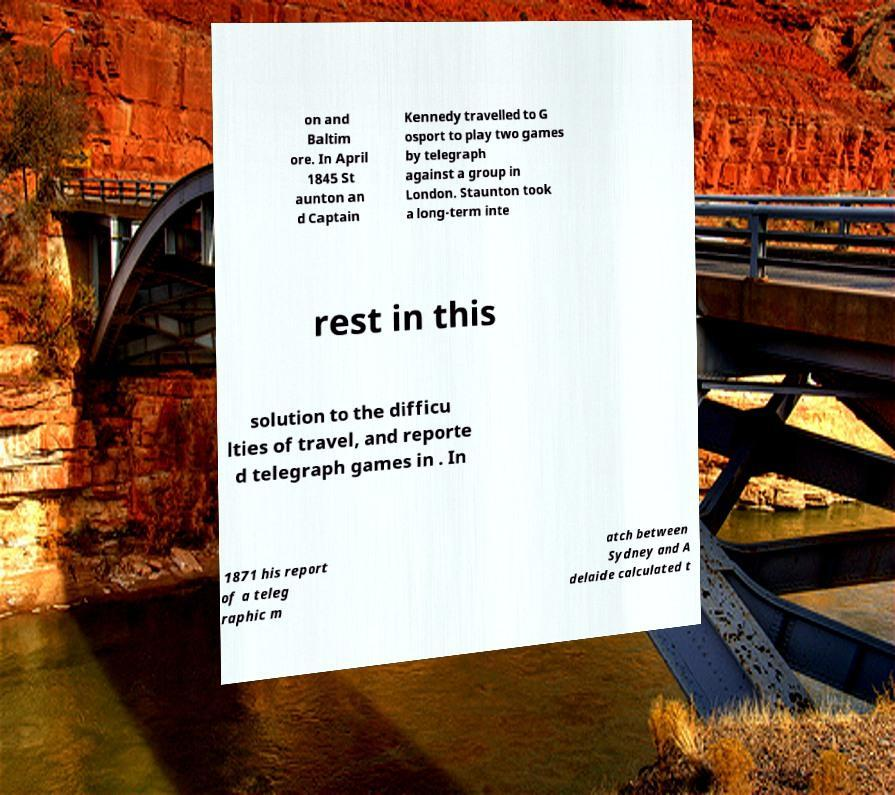Could you assist in decoding the text presented in this image and type it out clearly? on and Baltim ore. In April 1845 St aunton an d Captain Kennedy travelled to G osport to play two games by telegraph against a group in London. Staunton took a long-term inte rest in this solution to the difficu lties of travel, and reporte d telegraph games in . In 1871 his report of a teleg raphic m atch between Sydney and A delaide calculated t 